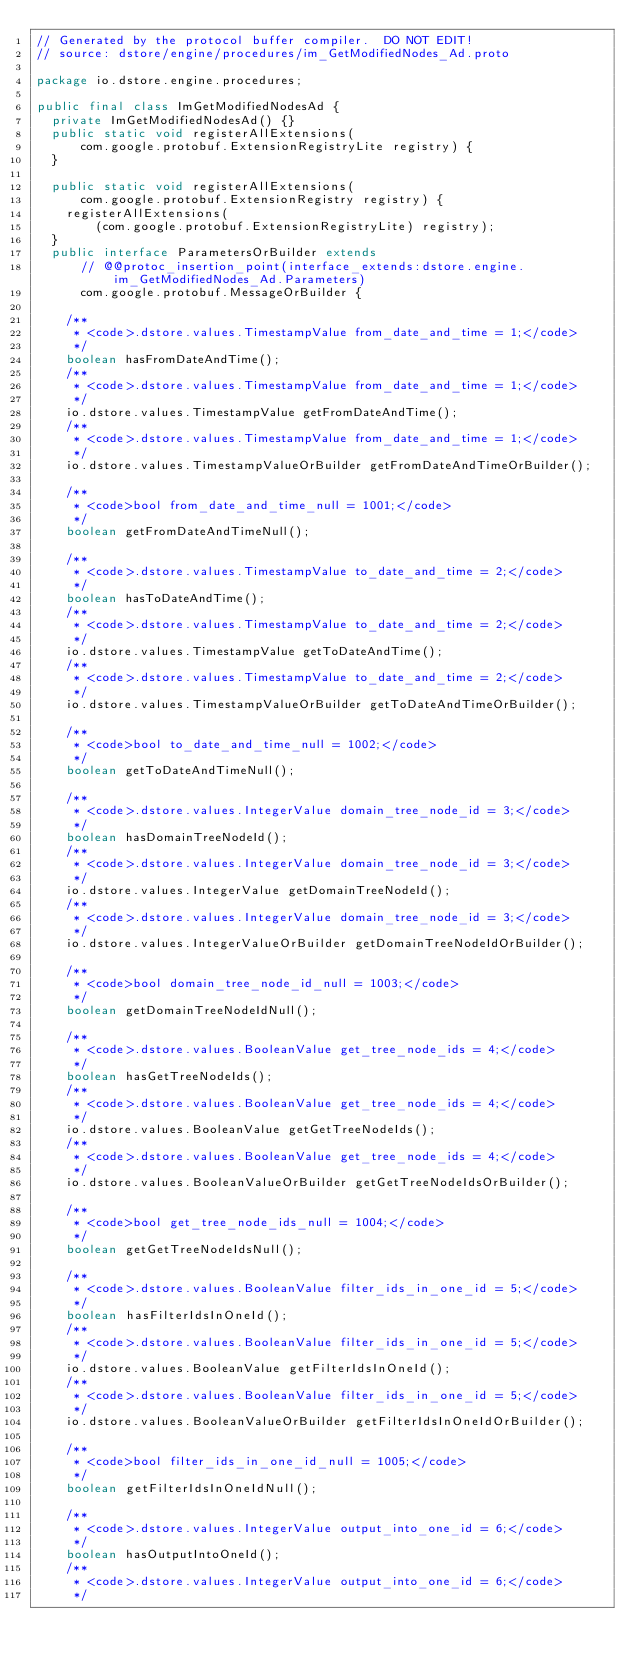Convert code to text. <code><loc_0><loc_0><loc_500><loc_500><_Java_>// Generated by the protocol buffer compiler.  DO NOT EDIT!
// source: dstore/engine/procedures/im_GetModifiedNodes_Ad.proto

package io.dstore.engine.procedures;

public final class ImGetModifiedNodesAd {
  private ImGetModifiedNodesAd() {}
  public static void registerAllExtensions(
      com.google.protobuf.ExtensionRegistryLite registry) {
  }

  public static void registerAllExtensions(
      com.google.protobuf.ExtensionRegistry registry) {
    registerAllExtensions(
        (com.google.protobuf.ExtensionRegistryLite) registry);
  }
  public interface ParametersOrBuilder extends
      // @@protoc_insertion_point(interface_extends:dstore.engine.im_GetModifiedNodes_Ad.Parameters)
      com.google.protobuf.MessageOrBuilder {

    /**
     * <code>.dstore.values.TimestampValue from_date_and_time = 1;</code>
     */
    boolean hasFromDateAndTime();
    /**
     * <code>.dstore.values.TimestampValue from_date_and_time = 1;</code>
     */
    io.dstore.values.TimestampValue getFromDateAndTime();
    /**
     * <code>.dstore.values.TimestampValue from_date_and_time = 1;</code>
     */
    io.dstore.values.TimestampValueOrBuilder getFromDateAndTimeOrBuilder();

    /**
     * <code>bool from_date_and_time_null = 1001;</code>
     */
    boolean getFromDateAndTimeNull();

    /**
     * <code>.dstore.values.TimestampValue to_date_and_time = 2;</code>
     */
    boolean hasToDateAndTime();
    /**
     * <code>.dstore.values.TimestampValue to_date_and_time = 2;</code>
     */
    io.dstore.values.TimestampValue getToDateAndTime();
    /**
     * <code>.dstore.values.TimestampValue to_date_and_time = 2;</code>
     */
    io.dstore.values.TimestampValueOrBuilder getToDateAndTimeOrBuilder();

    /**
     * <code>bool to_date_and_time_null = 1002;</code>
     */
    boolean getToDateAndTimeNull();

    /**
     * <code>.dstore.values.IntegerValue domain_tree_node_id = 3;</code>
     */
    boolean hasDomainTreeNodeId();
    /**
     * <code>.dstore.values.IntegerValue domain_tree_node_id = 3;</code>
     */
    io.dstore.values.IntegerValue getDomainTreeNodeId();
    /**
     * <code>.dstore.values.IntegerValue domain_tree_node_id = 3;</code>
     */
    io.dstore.values.IntegerValueOrBuilder getDomainTreeNodeIdOrBuilder();

    /**
     * <code>bool domain_tree_node_id_null = 1003;</code>
     */
    boolean getDomainTreeNodeIdNull();

    /**
     * <code>.dstore.values.BooleanValue get_tree_node_ids = 4;</code>
     */
    boolean hasGetTreeNodeIds();
    /**
     * <code>.dstore.values.BooleanValue get_tree_node_ids = 4;</code>
     */
    io.dstore.values.BooleanValue getGetTreeNodeIds();
    /**
     * <code>.dstore.values.BooleanValue get_tree_node_ids = 4;</code>
     */
    io.dstore.values.BooleanValueOrBuilder getGetTreeNodeIdsOrBuilder();

    /**
     * <code>bool get_tree_node_ids_null = 1004;</code>
     */
    boolean getGetTreeNodeIdsNull();

    /**
     * <code>.dstore.values.BooleanValue filter_ids_in_one_id = 5;</code>
     */
    boolean hasFilterIdsInOneId();
    /**
     * <code>.dstore.values.BooleanValue filter_ids_in_one_id = 5;</code>
     */
    io.dstore.values.BooleanValue getFilterIdsInOneId();
    /**
     * <code>.dstore.values.BooleanValue filter_ids_in_one_id = 5;</code>
     */
    io.dstore.values.BooleanValueOrBuilder getFilterIdsInOneIdOrBuilder();

    /**
     * <code>bool filter_ids_in_one_id_null = 1005;</code>
     */
    boolean getFilterIdsInOneIdNull();

    /**
     * <code>.dstore.values.IntegerValue output_into_one_id = 6;</code>
     */
    boolean hasOutputIntoOneId();
    /**
     * <code>.dstore.values.IntegerValue output_into_one_id = 6;</code>
     */</code> 